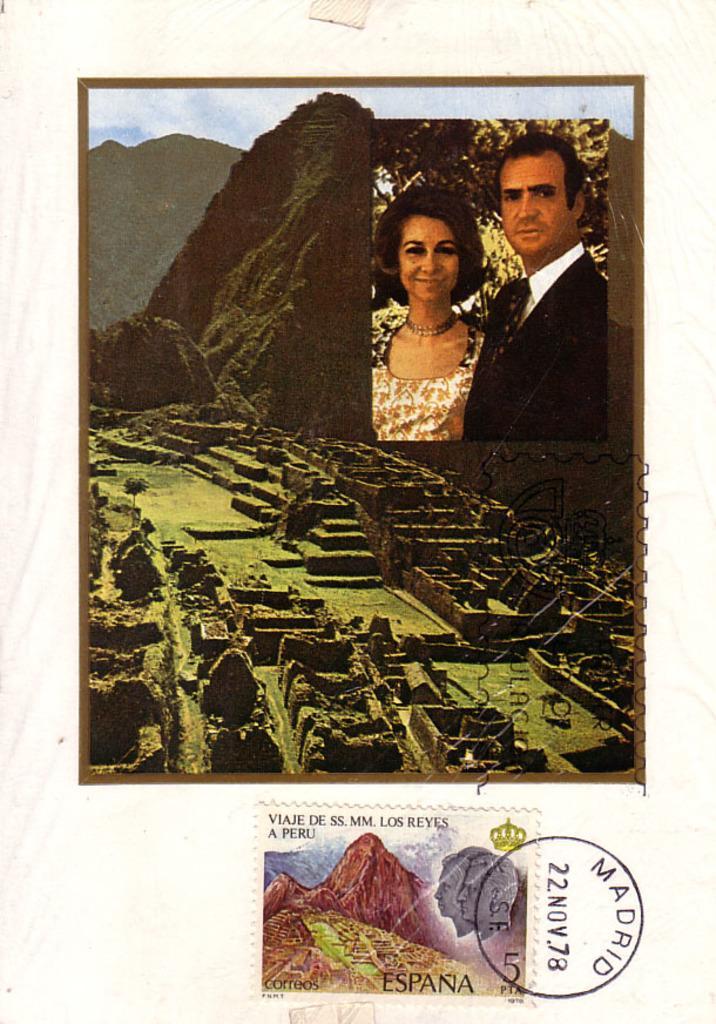Please provide a concise description of this image. In this image I can see the college image and I can see the two people, mountains, walls, ground, sky and the postal-stamp is attached to the cream color surface. 